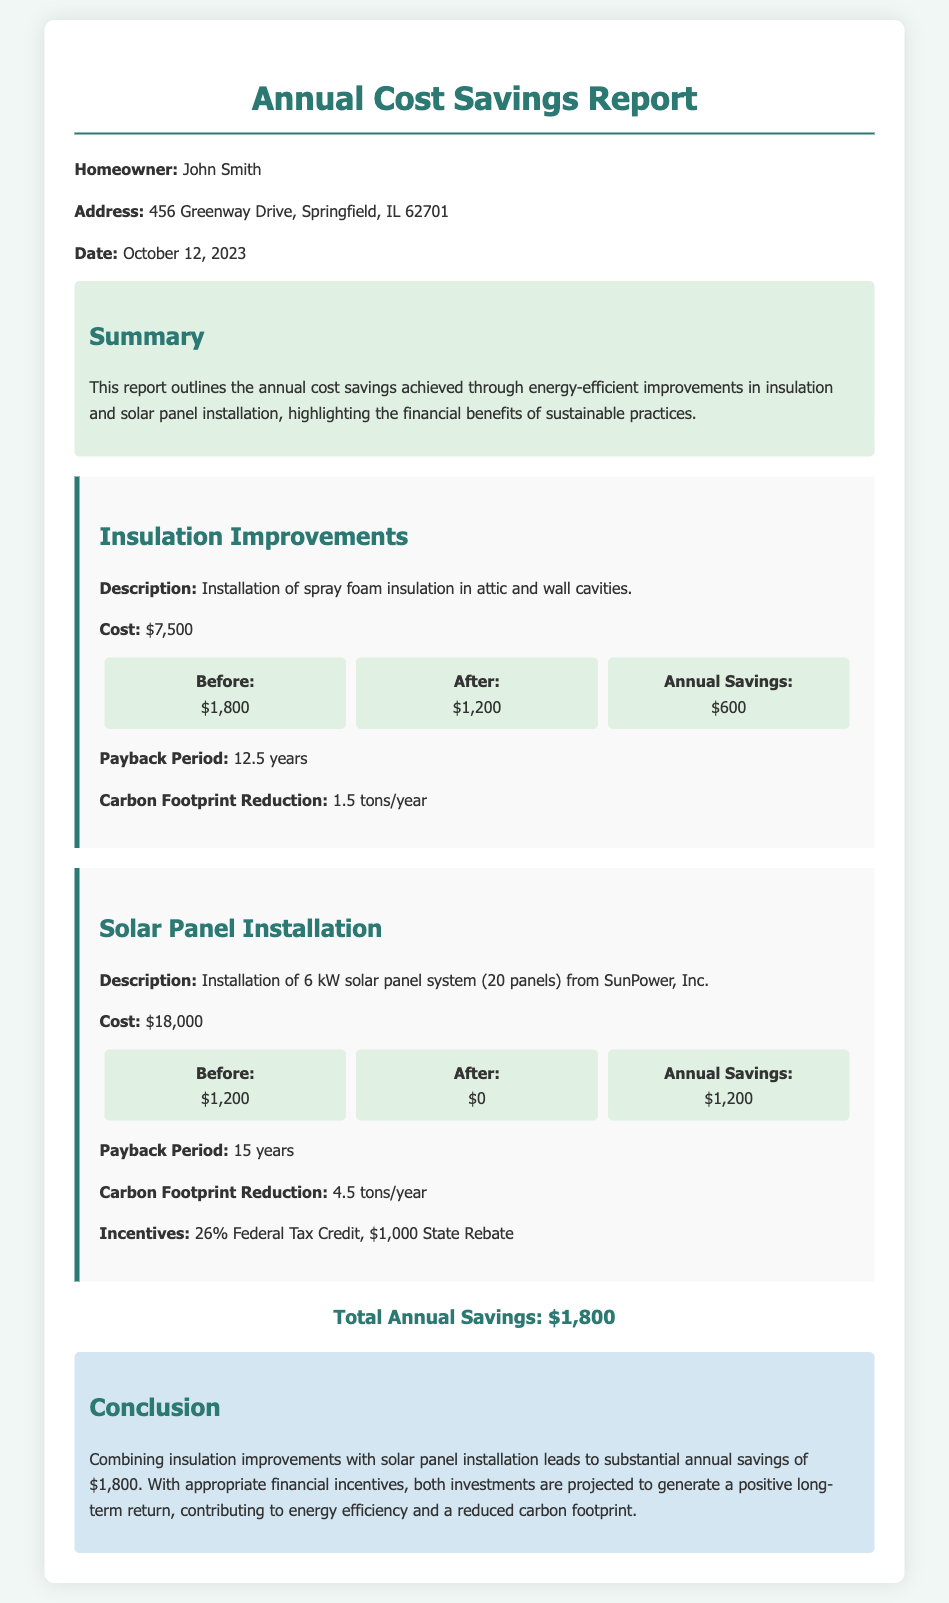What is the homeowner's name? The homeowner's name is provided in the document as John Smith.
Answer: John Smith What were the annual savings from insulation improvements? The document states the annual savings from insulation improvements as $600.
Answer: $600 What is the cost of the solar panel installation? The cost of the solar panel installation is mentioned in the document as $18,000.
Answer: $18,000 How much is the total annual savings from both improvements? The total annual savings is calculated in the document, stating that it's $1,800.
Answer: $1,800 What is the payback period for the insulation improvements? The payback period for insulation improvements is given in the document as 12.5 years.
Answer: 12.5 years What is the carbon footprint reduction from solar panel installation? The carbon footprint reduction from solar panel installation is stated as 4.5 tons/year in the report.
Answer: 4.5 tons/year What tax credit is mentioned for solar panel installation? The report mentions a 26% Federal Tax Credit for solar panel installation as part of the incentives.
Answer: 26% Federal Tax Credit What were the electricity costs before the insulation improvements? The document specifies the electricity costs before insulation improvements as $1,800.
Answer: $1,800 Which energy-efficient improvement has a longer payback period? The document compares the payback periods and indicates that solar panel installation has a longer payback period of 15 years.
Answer: Solar panel installation 